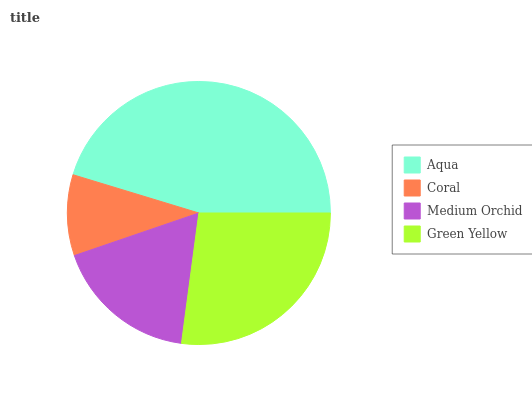Is Coral the minimum?
Answer yes or no. Yes. Is Aqua the maximum?
Answer yes or no. Yes. Is Medium Orchid the minimum?
Answer yes or no. No. Is Medium Orchid the maximum?
Answer yes or no. No. Is Medium Orchid greater than Coral?
Answer yes or no. Yes. Is Coral less than Medium Orchid?
Answer yes or no. Yes. Is Coral greater than Medium Orchid?
Answer yes or no. No. Is Medium Orchid less than Coral?
Answer yes or no. No. Is Green Yellow the high median?
Answer yes or no. Yes. Is Medium Orchid the low median?
Answer yes or no. Yes. Is Coral the high median?
Answer yes or no. No. Is Aqua the low median?
Answer yes or no. No. 